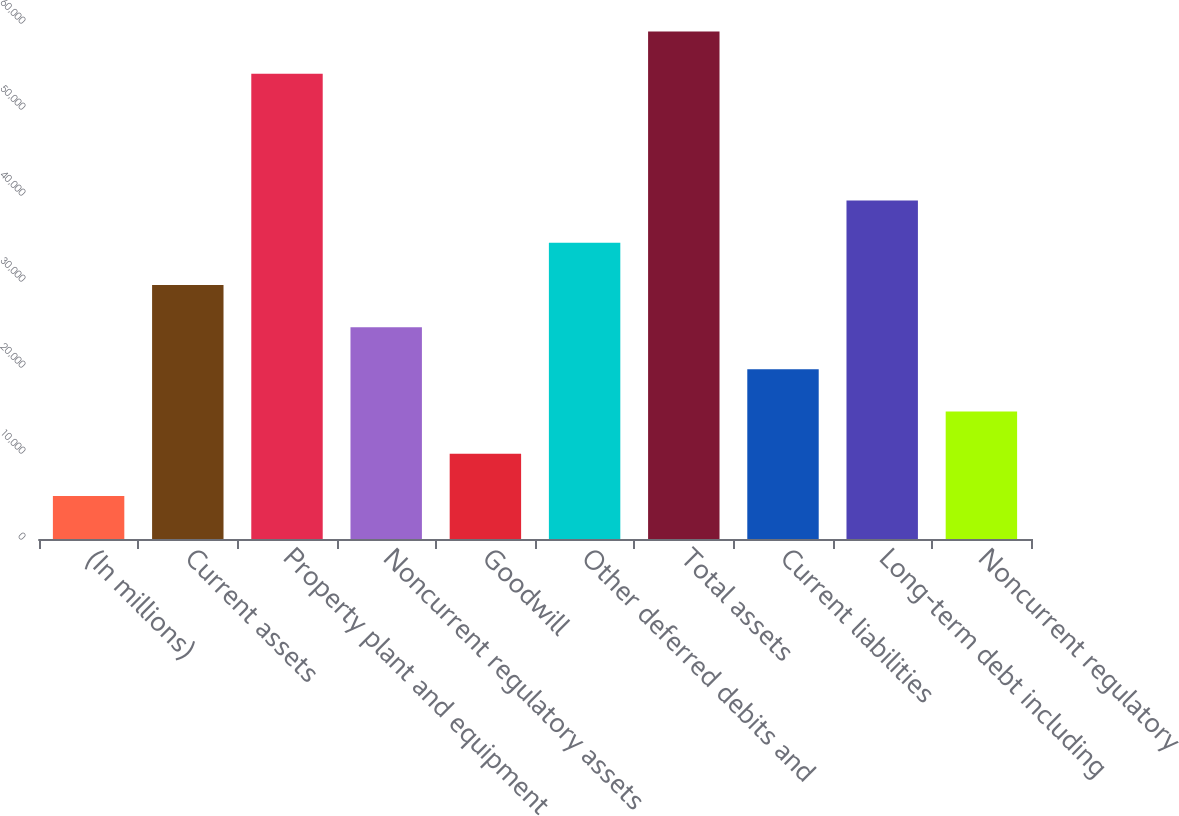Convert chart. <chart><loc_0><loc_0><loc_500><loc_500><bar_chart><fcel>(In millions)<fcel>Current assets<fcel>Property plant and equipment<fcel>Noncurrent regulatory assets<fcel>Goodwill<fcel>Other deferred debits and<fcel>Total assets<fcel>Current liabilities<fcel>Long-term debt including<fcel>Noncurrent regulatory<nl><fcel>4996.3<fcel>29542.8<fcel>54089.3<fcel>24633.5<fcel>9905.6<fcel>34452.1<fcel>58998.6<fcel>19724.2<fcel>39361.4<fcel>14814.9<nl></chart> 